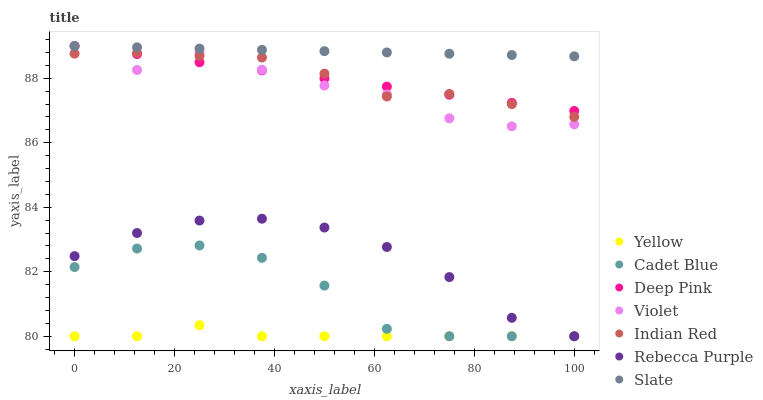Does Yellow have the minimum area under the curve?
Answer yes or no. Yes. Does Slate have the maximum area under the curve?
Answer yes or no. Yes. Does Slate have the minimum area under the curve?
Answer yes or no. No. Does Yellow have the maximum area under the curve?
Answer yes or no. No. Is Deep Pink the smoothest?
Answer yes or no. Yes. Is Violet the roughest?
Answer yes or no. Yes. Is Slate the smoothest?
Answer yes or no. No. Is Slate the roughest?
Answer yes or no. No. Does Cadet Blue have the lowest value?
Answer yes or no. Yes. Does Slate have the lowest value?
Answer yes or no. No. Does Violet have the highest value?
Answer yes or no. Yes. Does Yellow have the highest value?
Answer yes or no. No. Is Yellow less than Slate?
Answer yes or no. Yes. Is Slate greater than Cadet Blue?
Answer yes or no. Yes. Does Slate intersect Violet?
Answer yes or no. Yes. Is Slate less than Violet?
Answer yes or no. No. Is Slate greater than Violet?
Answer yes or no. No. Does Yellow intersect Slate?
Answer yes or no. No. 